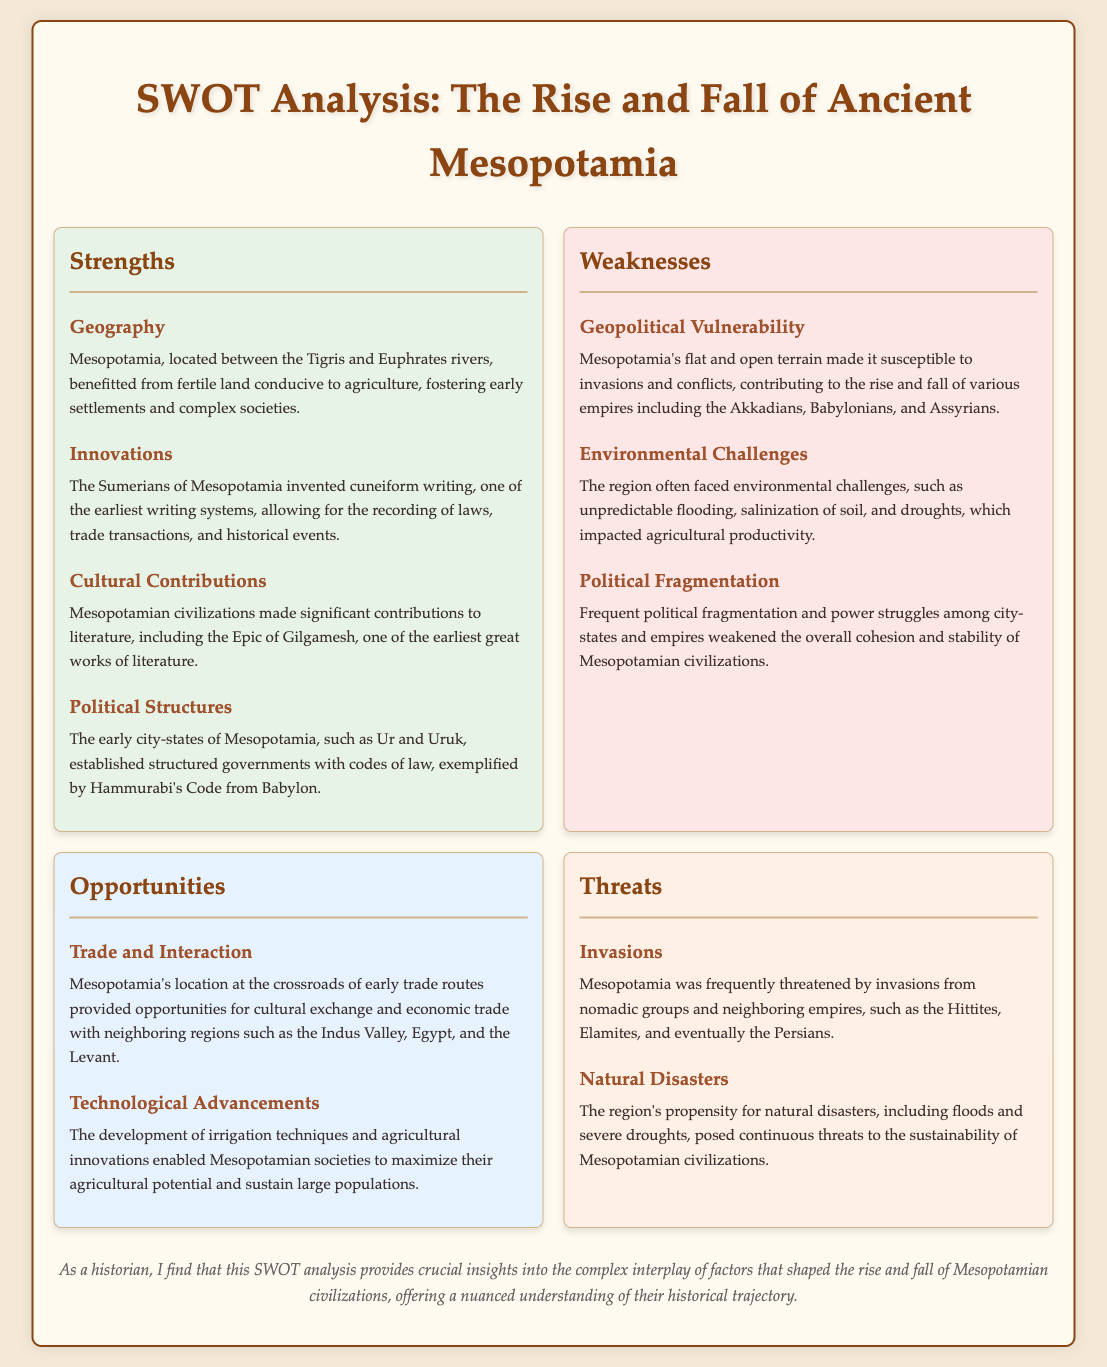What is one geographic advantage of Mesopotamia? The document states that Mesopotamia benefitted from fertile land conducive to agriculture, fostering early settlements and complex societies.
Answer: fertile land Who invented cuneiform writing? The document specifies that the Sumerians of Mesopotamia invented cuneiform writing, one of the earliest writing systems.
Answer: Sumerians What significant literary contribution did Mesopotamian civilizations make? It mentions that Mesopotamian civilizations made significant contributions to literature, including the Epic of Gilgamesh.
Answer: Epic of Gilgamesh What environmental challenge impacted agricultural productivity in Mesopotamia? The document lists salinization of soil as one of the environmental challenges that affected agricultural productivity.
Answer: salinization Name one opportunity for trade mentioned in the document. The document states that Mesopotamia's location at the crossroads of early trade routes provided opportunities for cultural exchange and economic trade.
Answer: trade routes Which group frequently threatened Mesopotamia through invasions? The document indicates that nomadic groups frequently threatened Mesopotamia through invasions.
Answer: nomadic groups What political structure did early city-states of Mesopotamia establish? It notes that early city-states established structured governments with codes of law, exemplified by Hammurabi's Code.
Answer: codes of law What is a major threat to Mesopotamian civilizations mentioned? The document highlights natural disasters as a major threat to the sustainability of Mesopotamian civilizations.
Answer: natural disasters 